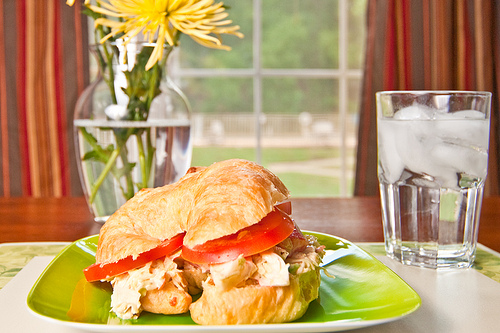What is in the vase that is on the left of the picture? The vase on the left side of the picture contains yellow flowers. 